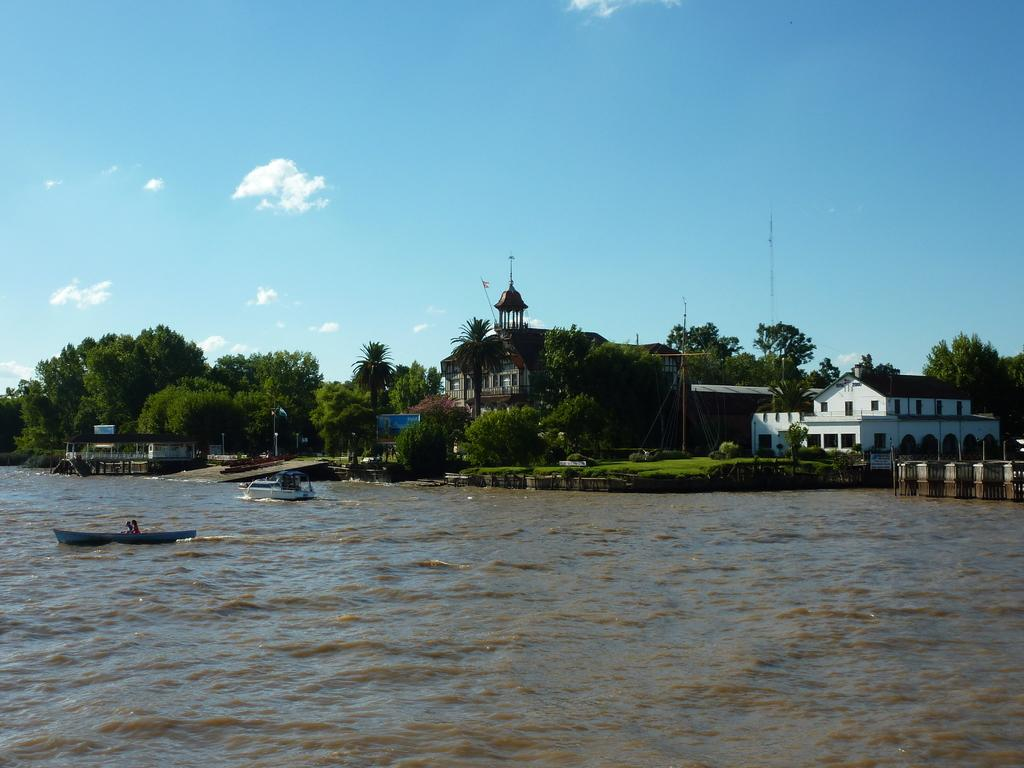What is in the water in the image? There are boats in the water. What can be seen in the background of the image? There are trees, poles, a blue object, and houses in the background. What is the color of the sky in the image? The sky is blue and cloudy in the image. What type of sticks can be seen in the image? There are no sticks present in the image. Is there any dirt visible in the image? There is no dirt visible in the image. 